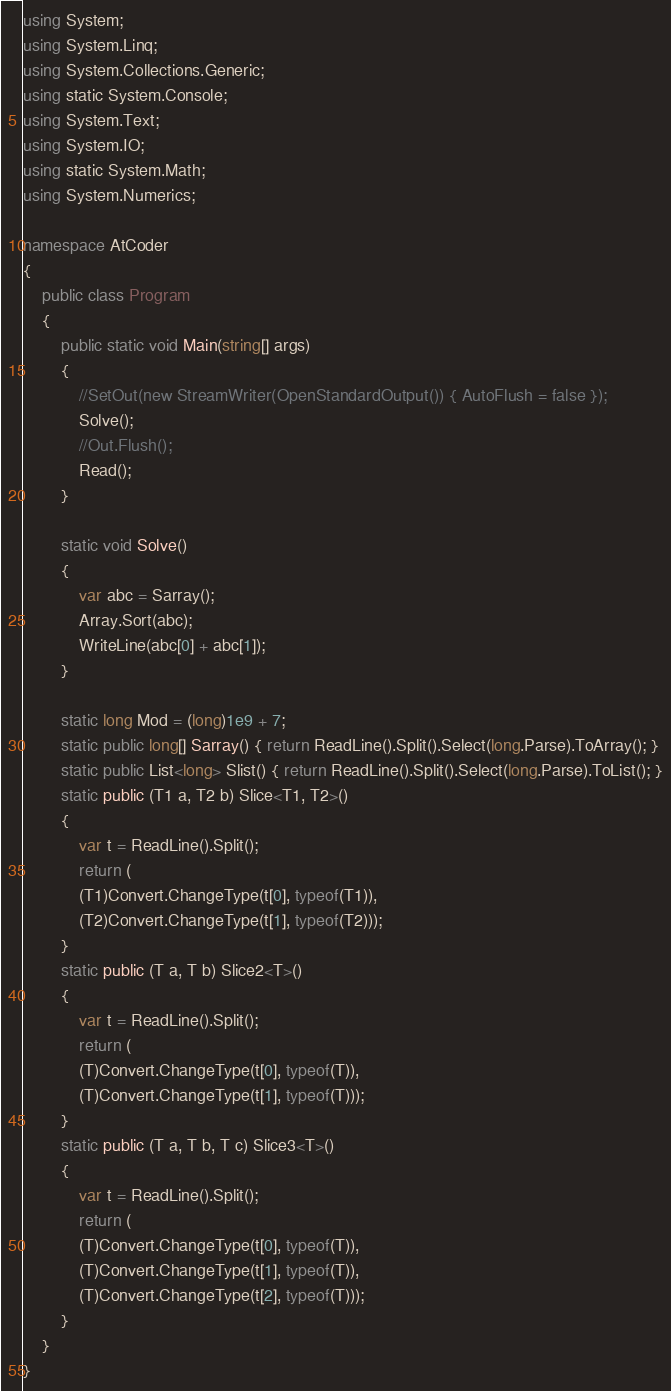<code> <loc_0><loc_0><loc_500><loc_500><_C#_>using System;
using System.Linq;
using System.Collections.Generic;
using static System.Console;
using System.Text;
using System.IO;
using static System.Math;
using System.Numerics;

namespace AtCoder
{
    public class Program
    {
        public static void Main(string[] args)
        {
            //SetOut(new StreamWriter(OpenStandardOutput()) { AutoFlush = false });
            Solve();
            //Out.Flush();
            Read();
        }

        static void Solve()
        {
            var abc = Sarray();
            Array.Sort(abc);
            WriteLine(abc[0] + abc[1]);
        }

        static long Mod = (long)1e9 + 7;
        static public long[] Sarray() { return ReadLine().Split().Select(long.Parse).ToArray(); }
        static public List<long> Slist() { return ReadLine().Split().Select(long.Parse).ToList(); }
        static public (T1 a, T2 b) Slice<T1, T2>()
        {
            var t = ReadLine().Split();
            return (
            (T1)Convert.ChangeType(t[0], typeof(T1)),
            (T2)Convert.ChangeType(t[1], typeof(T2)));
        }
        static public (T a, T b) Slice2<T>()
        {
            var t = ReadLine().Split();
            return (
            (T)Convert.ChangeType(t[0], typeof(T)),
            (T)Convert.ChangeType(t[1], typeof(T)));
        }
        static public (T a, T b, T c) Slice3<T>()
        {
            var t = ReadLine().Split();
            return (
            (T)Convert.ChangeType(t[0], typeof(T)),
            (T)Convert.ChangeType(t[1], typeof(T)),
            (T)Convert.ChangeType(t[2], typeof(T)));
        }
    }
}</code> 